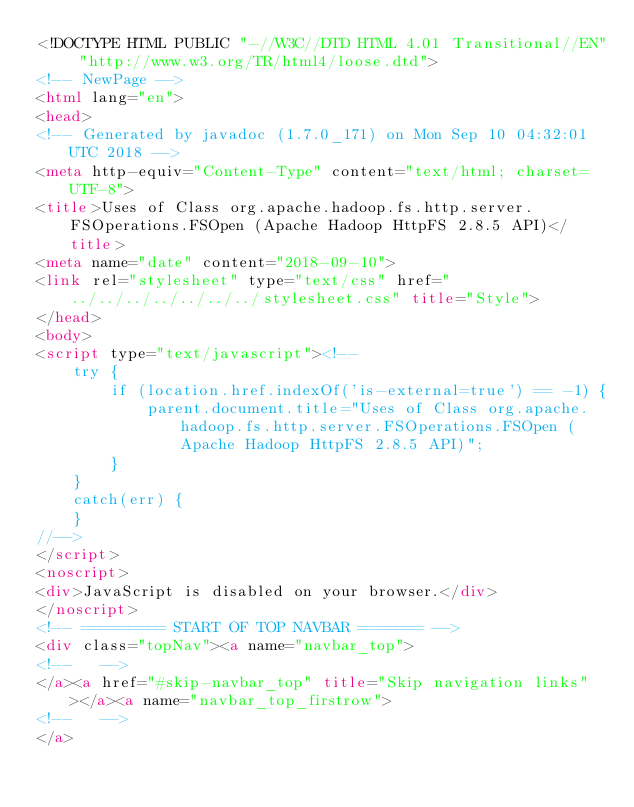<code> <loc_0><loc_0><loc_500><loc_500><_HTML_><!DOCTYPE HTML PUBLIC "-//W3C//DTD HTML 4.01 Transitional//EN" "http://www.w3.org/TR/html4/loose.dtd">
<!-- NewPage -->
<html lang="en">
<head>
<!-- Generated by javadoc (1.7.0_171) on Mon Sep 10 04:32:01 UTC 2018 -->
<meta http-equiv="Content-Type" content="text/html; charset=UTF-8">
<title>Uses of Class org.apache.hadoop.fs.http.server.FSOperations.FSOpen (Apache Hadoop HttpFS 2.8.5 API)</title>
<meta name="date" content="2018-09-10">
<link rel="stylesheet" type="text/css" href="../../../../../../../stylesheet.css" title="Style">
</head>
<body>
<script type="text/javascript"><!--
    try {
        if (location.href.indexOf('is-external=true') == -1) {
            parent.document.title="Uses of Class org.apache.hadoop.fs.http.server.FSOperations.FSOpen (Apache Hadoop HttpFS 2.8.5 API)";
        }
    }
    catch(err) {
    }
//-->
</script>
<noscript>
<div>JavaScript is disabled on your browser.</div>
</noscript>
<!-- ========= START OF TOP NAVBAR ======= -->
<div class="topNav"><a name="navbar_top">
<!--   -->
</a><a href="#skip-navbar_top" title="Skip navigation links"></a><a name="navbar_top_firstrow">
<!--   -->
</a></code> 